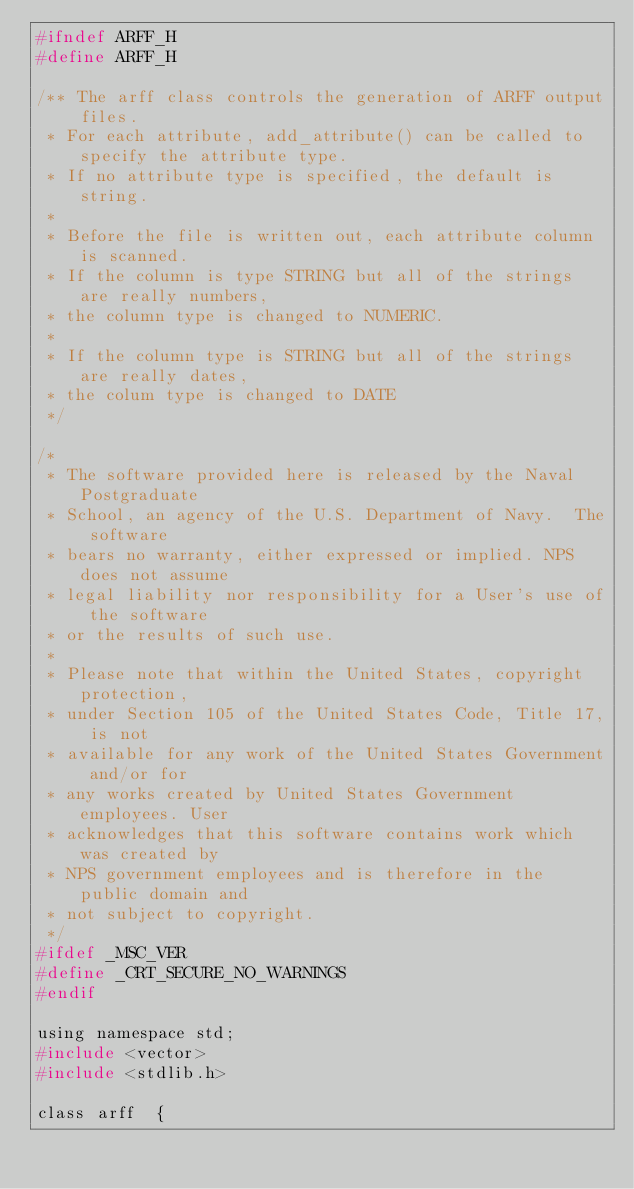Convert code to text. <code><loc_0><loc_0><loc_500><loc_500><_C_>#ifndef ARFF_H
#define ARFF_H

/** The arff class controls the generation of ARFF output files.
 * For each attribute, add_attribute() can be called to specify the attribute type.
 * If no attribute type is specified, the default is string.
 *
 * Before the file is written out, each attribute column is scanned.
 * If the column is type STRING but all of the strings are really numbers,
 * the column type is changed to NUMERIC.
 *
 * If the column type is STRING but all of the strings are really dates,
 * the colum type is changed to DATE
 */

/*
 * The software provided here is released by the Naval Postgraduate
 * School, an agency of the U.S. Department of Navy.  The software
 * bears no warranty, either expressed or implied. NPS does not assume
 * legal liability nor responsibility for a User's use of the software
 * or the results of such use.
 *
 * Please note that within the United States, copyright protection,
 * under Section 105 of the United States Code, Title 17, is not
 * available for any work of the United States Government and/or for
 * any works created by United States Government employees. User
 * acknowledges that this software contains work which was created by
 * NPS government employees and is therefore in the public domain and
 * not subject to copyright.
 */
#ifdef _MSC_VER
#define _CRT_SECURE_NO_WARNINGS
#endif

using namespace std;
#include <vector>
#include <stdlib.h>

class arff  {</code> 